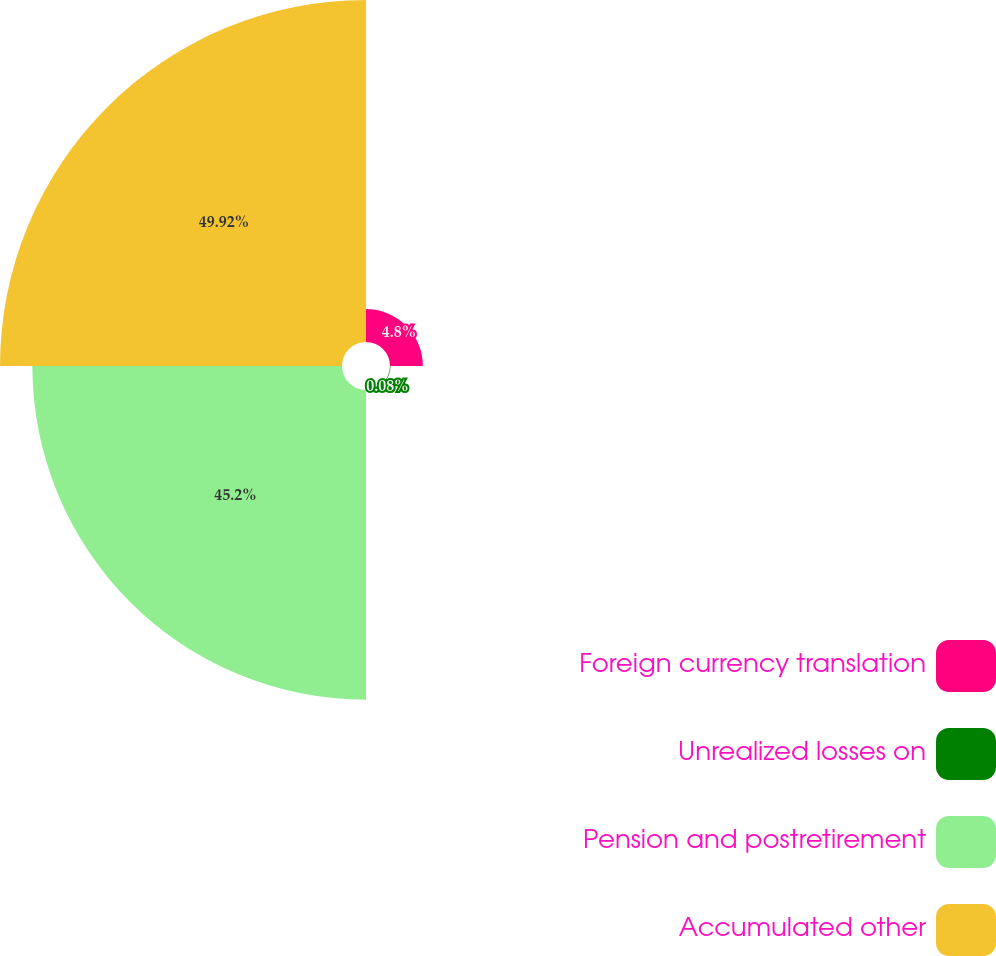Convert chart to OTSL. <chart><loc_0><loc_0><loc_500><loc_500><pie_chart><fcel>Foreign currency translation<fcel>Unrealized losses on<fcel>Pension and postretirement<fcel>Accumulated other<nl><fcel>4.8%<fcel>0.08%<fcel>45.2%<fcel>49.92%<nl></chart> 